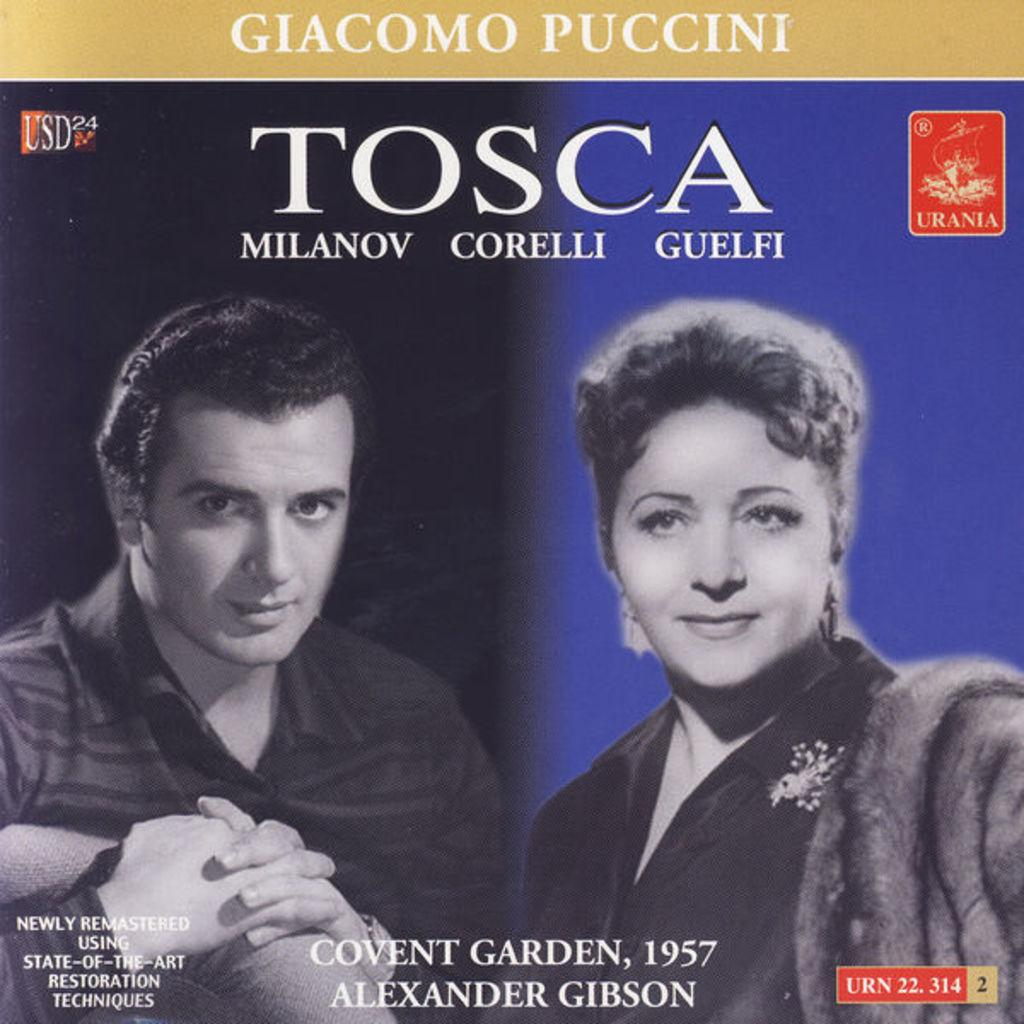What type of publication is the image from? The image is the cover page of a magazine. What can be seen in the two black and white images on the page? There are two black and white images of a man and a woman. What is written below the images on the page? Some text is mentioned below the page. What word is prominently displayed on the page? The word "TOSCA" is written on the page. How many chickens are visible in the images on the page? There are no chickens visible in the images on the page; it features two black and white images of a man and a woman. What type of books can be found in the library depicted in the images? There is no library depicted in the images; they show a man and a woman. 